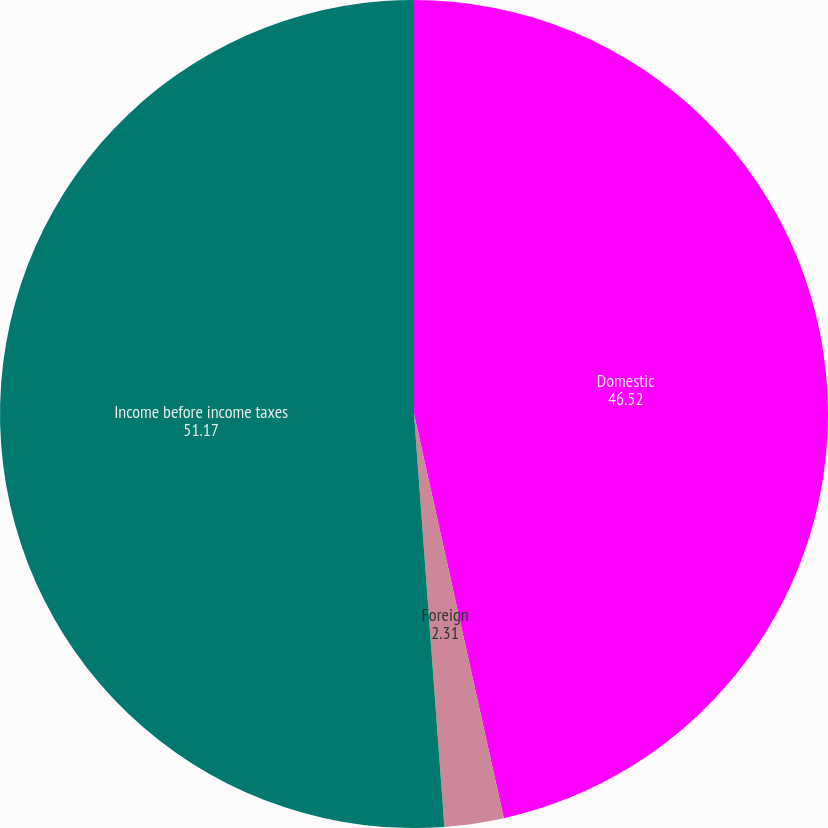<chart> <loc_0><loc_0><loc_500><loc_500><pie_chart><fcel>Domestic<fcel>Foreign<fcel>Income before income taxes<nl><fcel>46.52%<fcel>2.31%<fcel>51.17%<nl></chart> 